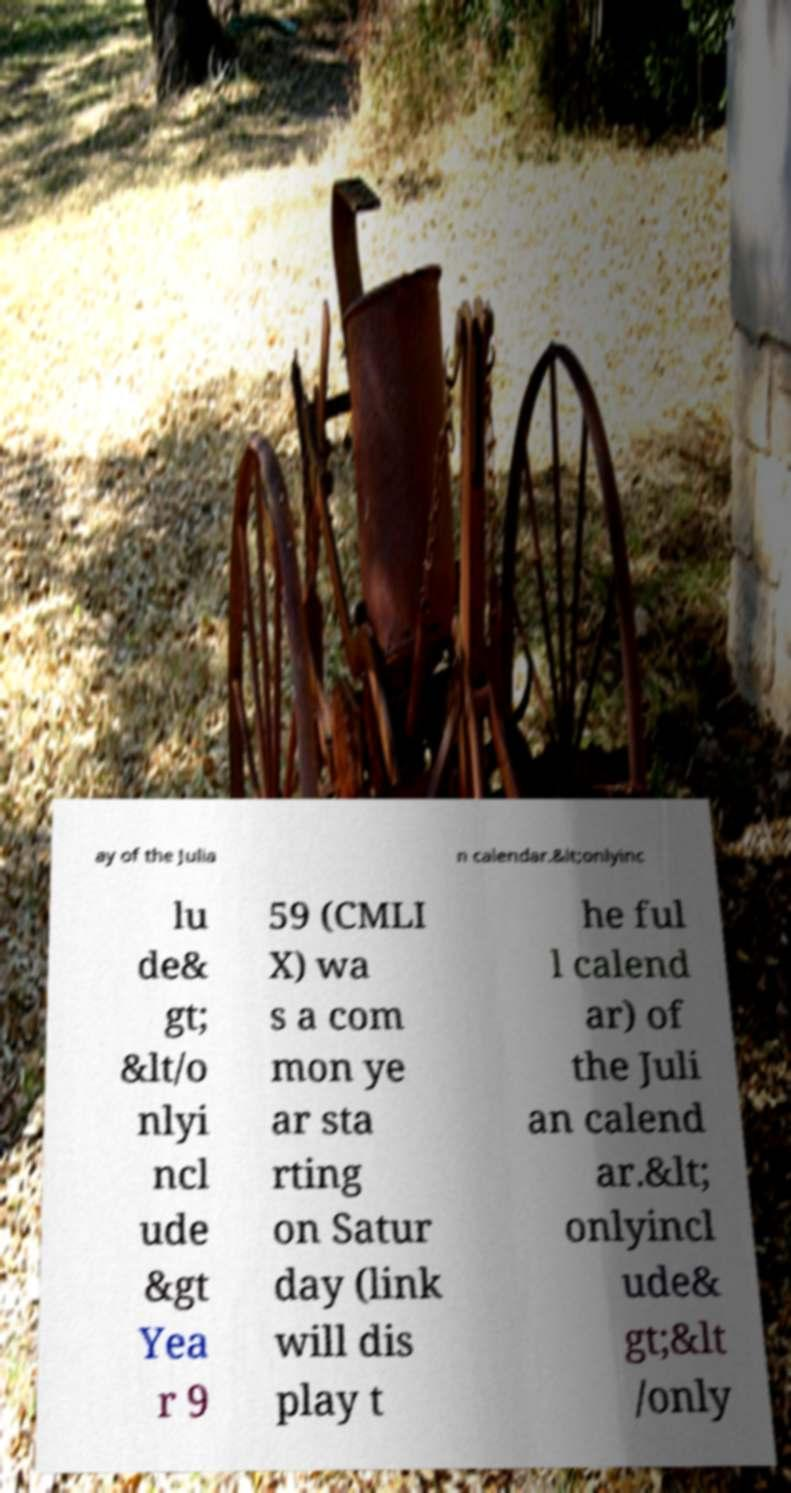I need the written content from this picture converted into text. Can you do that? ay of the Julia n calendar.&lt;onlyinc lu de& gt; &lt/o nlyi ncl ude &gt Yea r 9 59 (CMLI X) wa s a com mon ye ar sta rting on Satur day (link will dis play t he ful l calend ar) of the Juli an calend ar.&lt; onlyincl ude& gt;&lt /only 